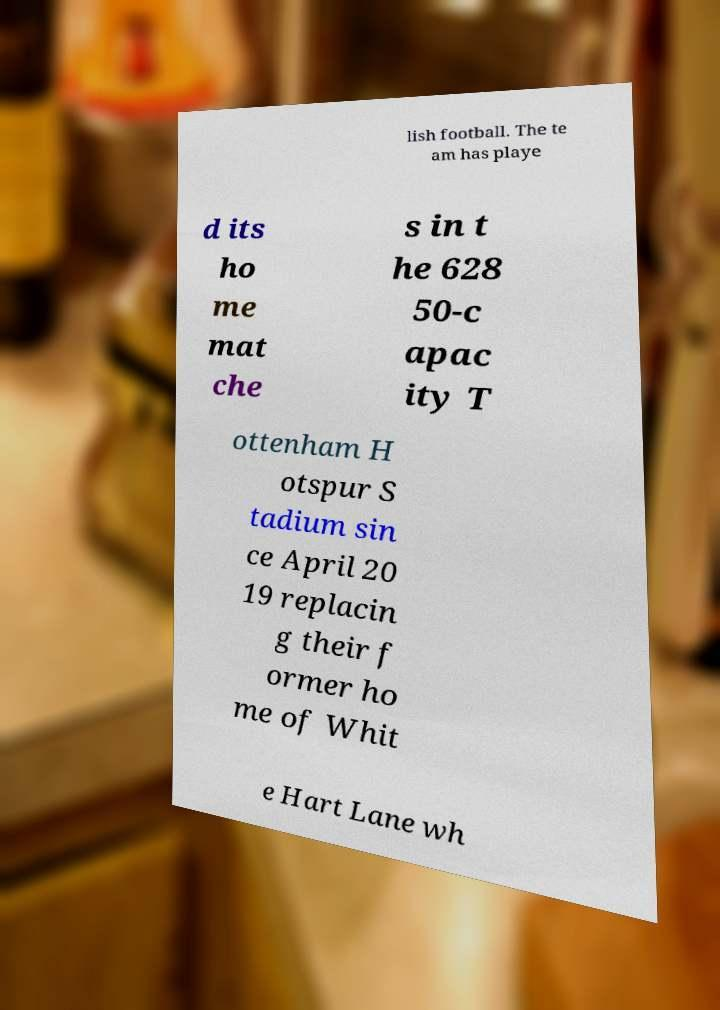There's text embedded in this image that I need extracted. Can you transcribe it verbatim? lish football. The te am has playe d its ho me mat che s in t he 628 50-c apac ity T ottenham H otspur S tadium sin ce April 20 19 replacin g their f ormer ho me of Whit e Hart Lane wh 